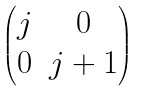Convert formula to latex. <formula><loc_0><loc_0><loc_500><loc_500>\begin{pmatrix} j & 0 \\ 0 & j + 1 \end{pmatrix}</formula> 